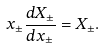Convert formula to latex. <formula><loc_0><loc_0><loc_500><loc_500>x _ { \pm } \frac { d X _ { \pm } } { d x _ { \pm } } = X _ { \pm } .</formula> 